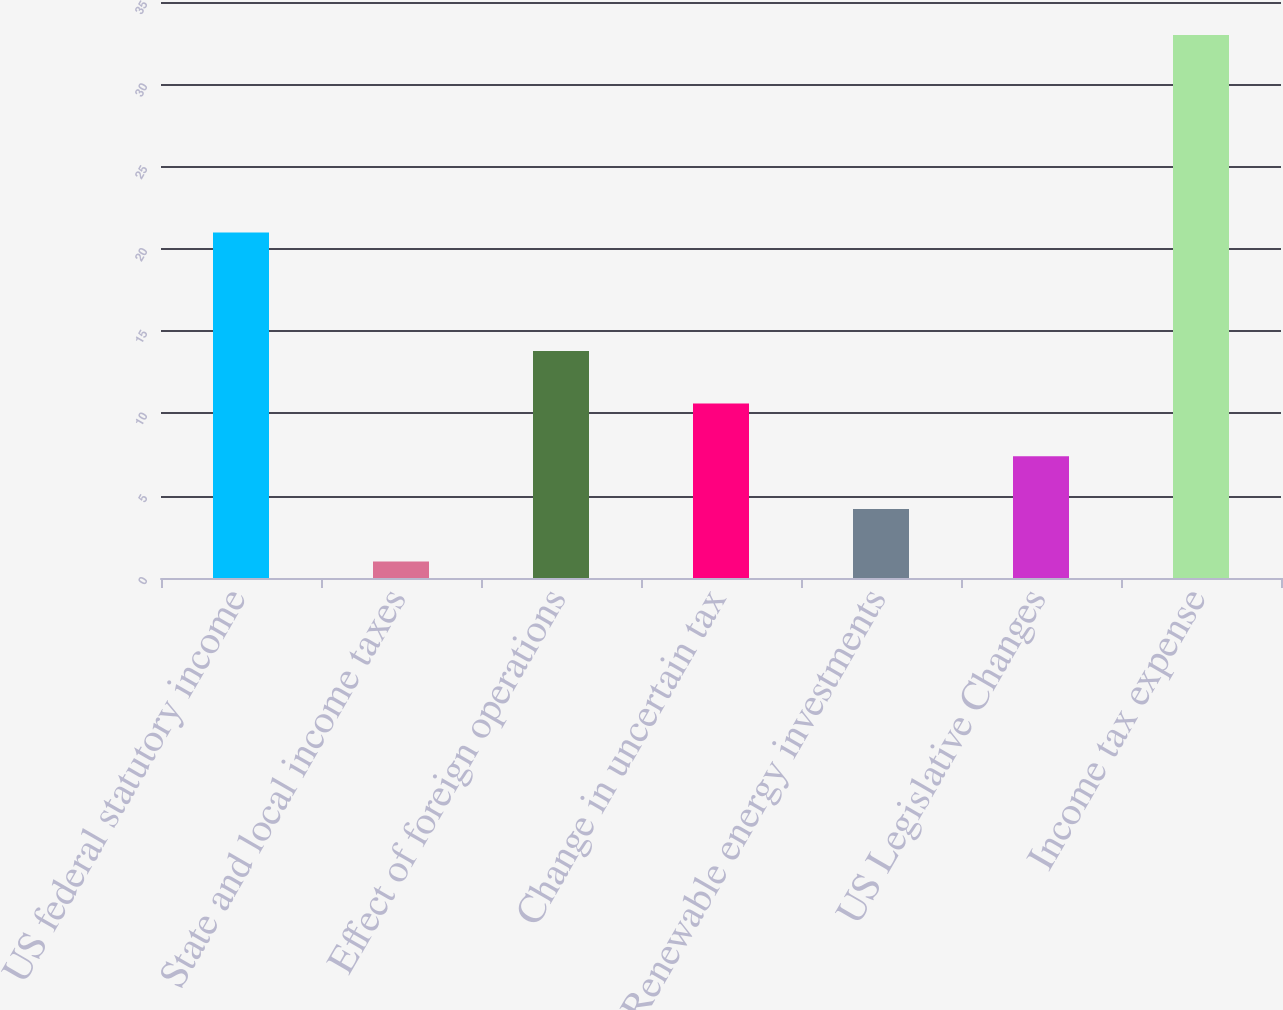<chart> <loc_0><loc_0><loc_500><loc_500><bar_chart><fcel>US federal statutory income<fcel>State and local income taxes<fcel>Effect of foreign operations<fcel>Change in uncertain tax<fcel>Renewable energy investments<fcel>US Legislative Changes<fcel>Income tax expense<nl><fcel>21<fcel>1<fcel>13.8<fcel>10.6<fcel>4.2<fcel>7.4<fcel>33<nl></chart> 